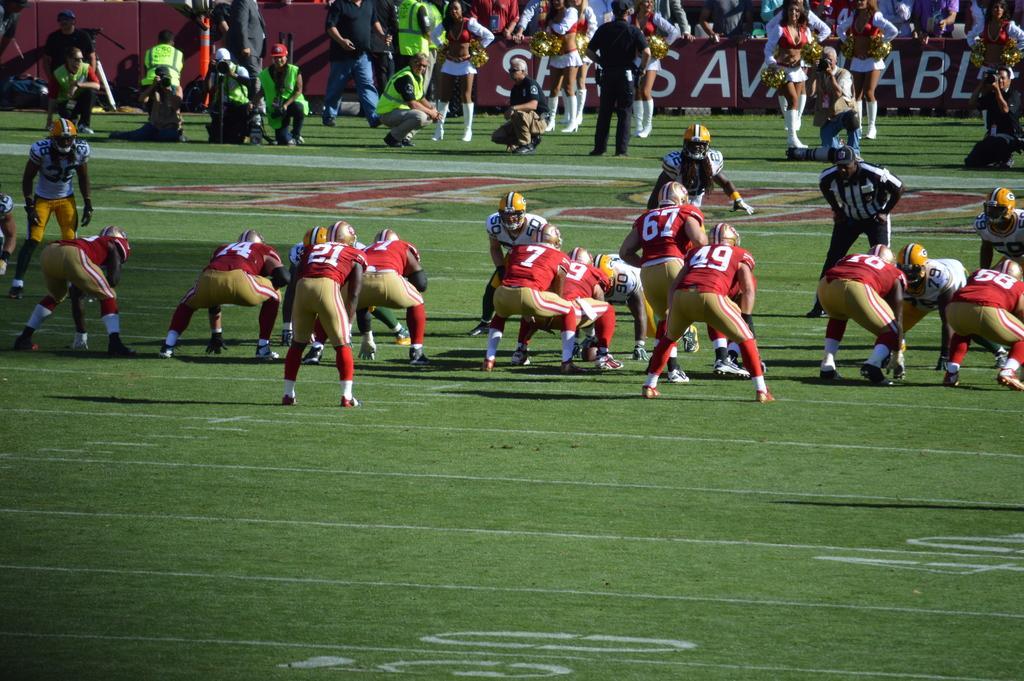Can you describe this image briefly? In this picture we can see some people are playing game, at the bottom there is grass, in the background we can see some people are standing, we can also see hoarding in the background, these people wore helmets, 